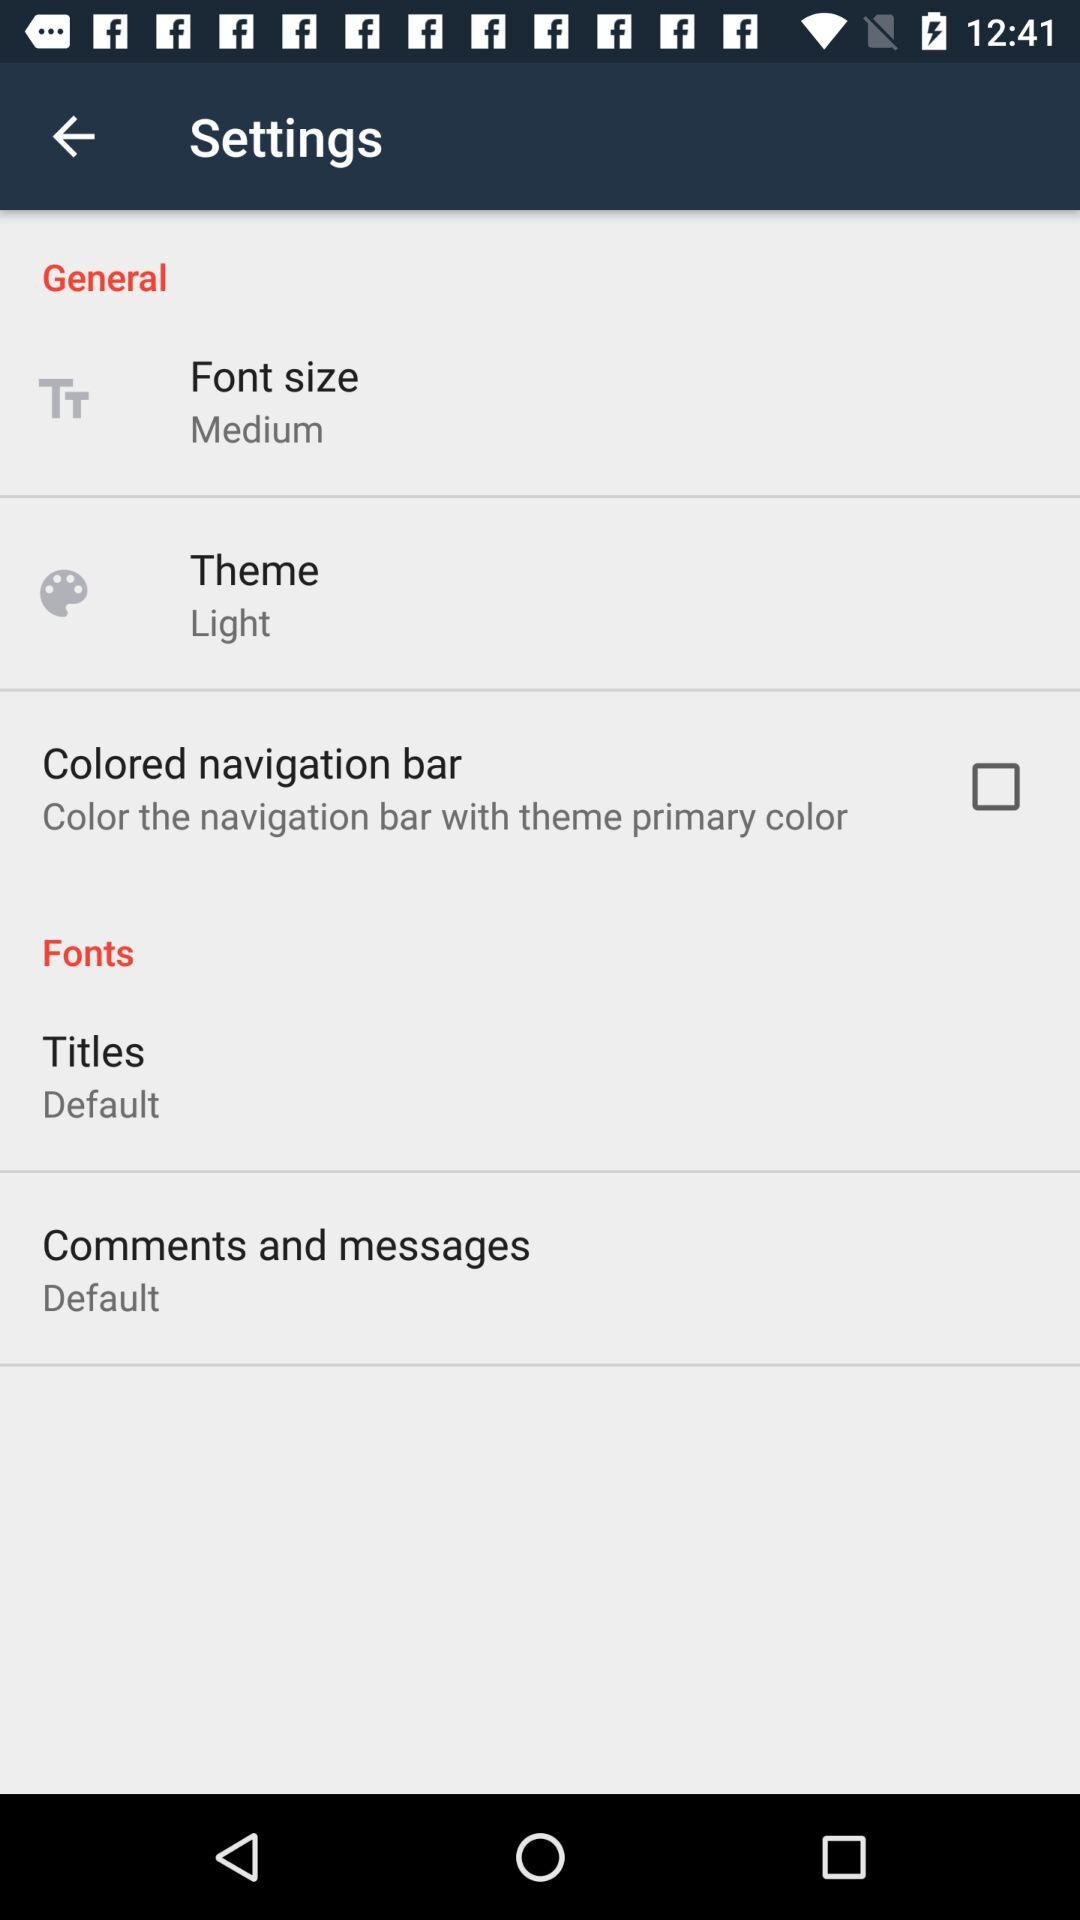What is the status of "General"?
When the provided information is insufficient, respond with <no answer>. <no answer> 